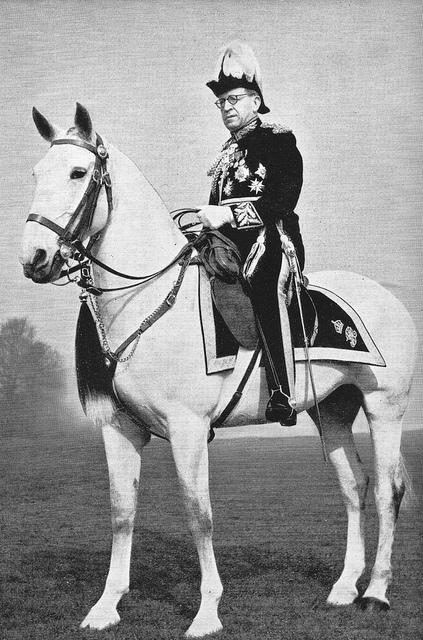What did this man serve in?

Choices:
A) tennis
B) military
C) dog grooming
D) horse show military 